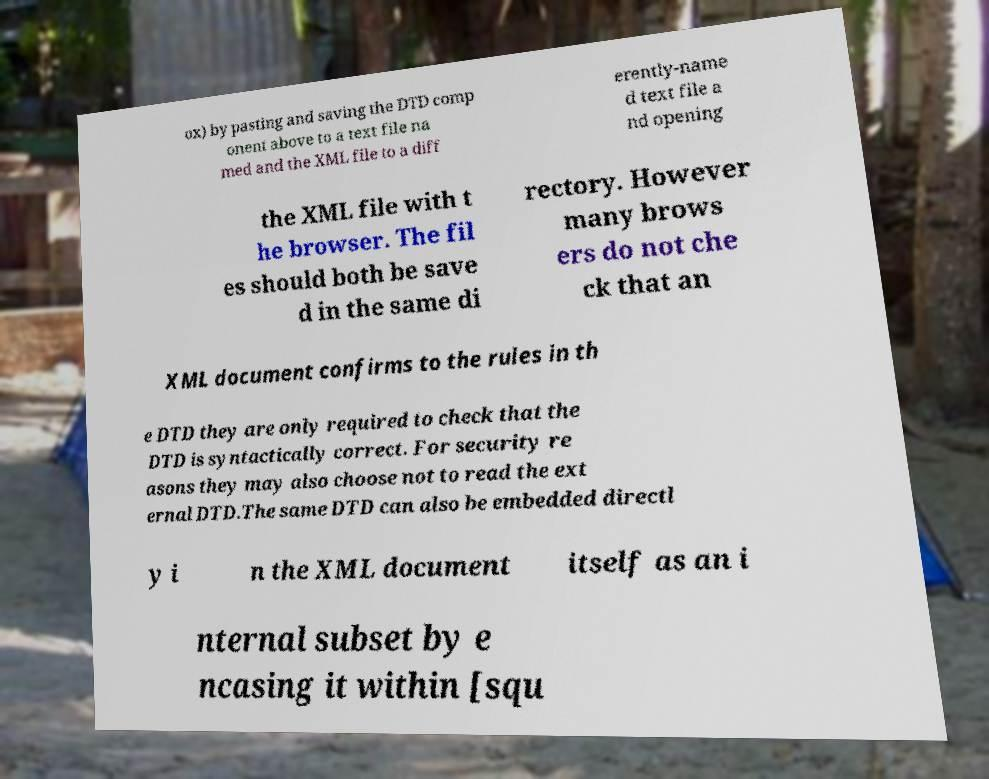Could you assist in decoding the text presented in this image and type it out clearly? ox) by pasting and saving the DTD comp onent above to a text file na med and the XML file to a diff erently-name d text file a nd opening the XML file with t he browser. The fil es should both be save d in the same di rectory. However many brows ers do not che ck that an XML document confirms to the rules in th e DTD they are only required to check that the DTD is syntactically correct. For security re asons they may also choose not to read the ext ernal DTD.The same DTD can also be embedded directl y i n the XML document itself as an i nternal subset by e ncasing it within [squ 